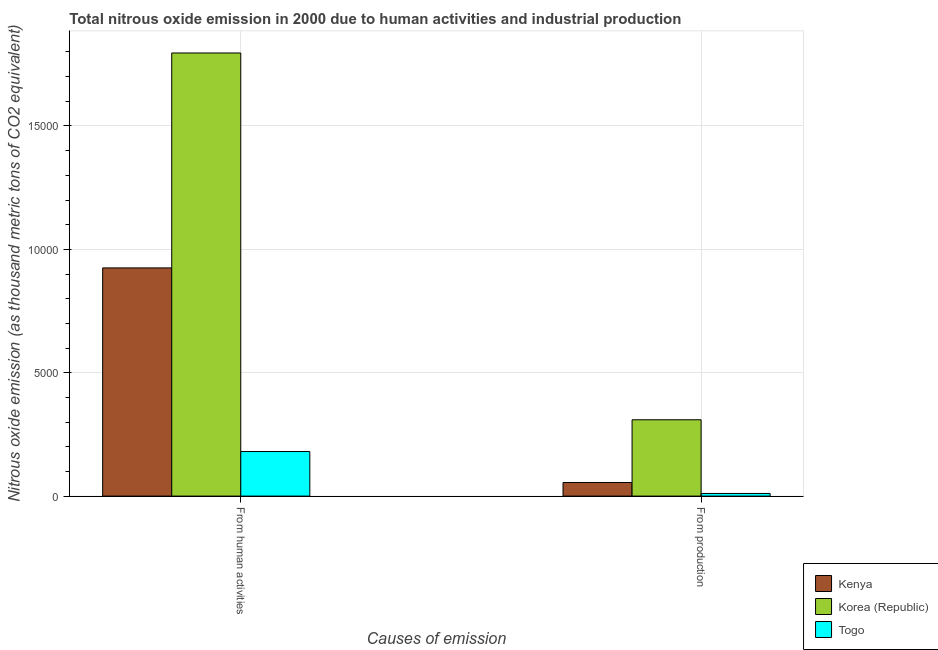How many different coloured bars are there?
Ensure brevity in your answer.  3. Are the number of bars per tick equal to the number of legend labels?
Your answer should be very brief. Yes. How many bars are there on the 2nd tick from the left?
Offer a very short reply. 3. What is the label of the 1st group of bars from the left?
Your response must be concise. From human activities. What is the amount of emissions from human activities in Togo?
Ensure brevity in your answer.  1807. Across all countries, what is the maximum amount of emissions from human activities?
Ensure brevity in your answer.  1.80e+04. Across all countries, what is the minimum amount of emissions generated from industries?
Keep it short and to the point. 107.3. In which country was the amount of emissions generated from industries minimum?
Your answer should be very brief. Togo. What is the total amount of emissions from human activities in the graph?
Offer a very short reply. 2.90e+04. What is the difference between the amount of emissions from human activities in Kenya and that in Korea (Republic)?
Make the answer very short. -8710.5. What is the difference between the amount of emissions from human activities in Togo and the amount of emissions generated from industries in Korea (Republic)?
Your response must be concise. -1286.7. What is the average amount of emissions generated from industries per country?
Give a very brief answer. 1250.83. What is the difference between the amount of emissions from human activities and amount of emissions generated from industries in Korea (Republic)?
Offer a terse response. 1.49e+04. What is the ratio of the amount of emissions from human activities in Korea (Republic) to that in Togo?
Ensure brevity in your answer.  9.94. Is the amount of emissions from human activities in Togo less than that in Kenya?
Provide a succinct answer. Yes. What does the 1st bar from the left in From human activities represents?
Ensure brevity in your answer.  Kenya. What does the 1st bar from the right in From production represents?
Your answer should be compact. Togo. Are the values on the major ticks of Y-axis written in scientific E-notation?
Keep it short and to the point. No. Does the graph contain any zero values?
Ensure brevity in your answer.  No. How many legend labels are there?
Your answer should be very brief. 3. How are the legend labels stacked?
Your answer should be very brief. Vertical. What is the title of the graph?
Offer a terse response. Total nitrous oxide emission in 2000 due to human activities and industrial production. Does "Myanmar" appear as one of the legend labels in the graph?
Your response must be concise. No. What is the label or title of the X-axis?
Provide a short and direct response. Causes of emission. What is the label or title of the Y-axis?
Ensure brevity in your answer.  Nitrous oxide emission (as thousand metric tons of CO2 equivalent). What is the Nitrous oxide emission (as thousand metric tons of CO2 equivalent) in Kenya in From human activities?
Provide a short and direct response. 9247.6. What is the Nitrous oxide emission (as thousand metric tons of CO2 equivalent) in Korea (Republic) in From human activities?
Your answer should be compact. 1.80e+04. What is the Nitrous oxide emission (as thousand metric tons of CO2 equivalent) of Togo in From human activities?
Provide a short and direct response. 1807. What is the Nitrous oxide emission (as thousand metric tons of CO2 equivalent) in Kenya in From production?
Make the answer very short. 551.5. What is the Nitrous oxide emission (as thousand metric tons of CO2 equivalent) in Korea (Republic) in From production?
Provide a short and direct response. 3093.7. What is the Nitrous oxide emission (as thousand metric tons of CO2 equivalent) in Togo in From production?
Make the answer very short. 107.3. Across all Causes of emission, what is the maximum Nitrous oxide emission (as thousand metric tons of CO2 equivalent) of Kenya?
Provide a succinct answer. 9247.6. Across all Causes of emission, what is the maximum Nitrous oxide emission (as thousand metric tons of CO2 equivalent) of Korea (Republic)?
Make the answer very short. 1.80e+04. Across all Causes of emission, what is the maximum Nitrous oxide emission (as thousand metric tons of CO2 equivalent) of Togo?
Ensure brevity in your answer.  1807. Across all Causes of emission, what is the minimum Nitrous oxide emission (as thousand metric tons of CO2 equivalent) in Kenya?
Your answer should be compact. 551.5. Across all Causes of emission, what is the minimum Nitrous oxide emission (as thousand metric tons of CO2 equivalent) in Korea (Republic)?
Your answer should be compact. 3093.7. Across all Causes of emission, what is the minimum Nitrous oxide emission (as thousand metric tons of CO2 equivalent) of Togo?
Offer a terse response. 107.3. What is the total Nitrous oxide emission (as thousand metric tons of CO2 equivalent) in Kenya in the graph?
Ensure brevity in your answer.  9799.1. What is the total Nitrous oxide emission (as thousand metric tons of CO2 equivalent) in Korea (Republic) in the graph?
Offer a very short reply. 2.11e+04. What is the total Nitrous oxide emission (as thousand metric tons of CO2 equivalent) in Togo in the graph?
Give a very brief answer. 1914.3. What is the difference between the Nitrous oxide emission (as thousand metric tons of CO2 equivalent) of Kenya in From human activities and that in From production?
Make the answer very short. 8696.1. What is the difference between the Nitrous oxide emission (as thousand metric tons of CO2 equivalent) of Korea (Republic) in From human activities and that in From production?
Offer a terse response. 1.49e+04. What is the difference between the Nitrous oxide emission (as thousand metric tons of CO2 equivalent) in Togo in From human activities and that in From production?
Provide a succinct answer. 1699.7. What is the difference between the Nitrous oxide emission (as thousand metric tons of CO2 equivalent) of Kenya in From human activities and the Nitrous oxide emission (as thousand metric tons of CO2 equivalent) of Korea (Republic) in From production?
Offer a terse response. 6153.9. What is the difference between the Nitrous oxide emission (as thousand metric tons of CO2 equivalent) in Kenya in From human activities and the Nitrous oxide emission (as thousand metric tons of CO2 equivalent) in Togo in From production?
Give a very brief answer. 9140.3. What is the difference between the Nitrous oxide emission (as thousand metric tons of CO2 equivalent) of Korea (Republic) in From human activities and the Nitrous oxide emission (as thousand metric tons of CO2 equivalent) of Togo in From production?
Your answer should be compact. 1.79e+04. What is the average Nitrous oxide emission (as thousand metric tons of CO2 equivalent) in Kenya per Causes of emission?
Give a very brief answer. 4899.55. What is the average Nitrous oxide emission (as thousand metric tons of CO2 equivalent) in Korea (Republic) per Causes of emission?
Ensure brevity in your answer.  1.05e+04. What is the average Nitrous oxide emission (as thousand metric tons of CO2 equivalent) of Togo per Causes of emission?
Offer a very short reply. 957.15. What is the difference between the Nitrous oxide emission (as thousand metric tons of CO2 equivalent) in Kenya and Nitrous oxide emission (as thousand metric tons of CO2 equivalent) in Korea (Republic) in From human activities?
Offer a terse response. -8710.5. What is the difference between the Nitrous oxide emission (as thousand metric tons of CO2 equivalent) in Kenya and Nitrous oxide emission (as thousand metric tons of CO2 equivalent) in Togo in From human activities?
Ensure brevity in your answer.  7440.6. What is the difference between the Nitrous oxide emission (as thousand metric tons of CO2 equivalent) of Korea (Republic) and Nitrous oxide emission (as thousand metric tons of CO2 equivalent) of Togo in From human activities?
Give a very brief answer. 1.62e+04. What is the difference between the Nitrous oxide emission (as thousand metric tons of CO2 equivalent) of Kenya and Nitrous oxide emission (as thousand metric tons of CO2 equivalent) of Korea (Republic) in From production?
Your answer should be very brief. -2542.2. What is the difference between the Nitrous oxide emission (as thousand metric tons of CO2 equivalent) in Kenya and Nitrous oxide emission (as thousand metric tons of CO2 equivalent) in Togo in From production?
Offer a terse response. 444.2. What is the difference between the Nitrous oxide emission (as thousand metric tons of CO2 equivalent) of Korea (Republic) and Nitrous oxide emission (as thousand metric tons of CO2 equivalent) of Togo in From production?
Your response must be concise. 2986.4. What is the ratio of the Nitrous oxide emission (as thousand metric tons of CO2 equivalent) of Kenya in From human activities to that in From production?
Keep it short and to the point. 16.77. What is the ratio of the Nitrous oxide emission (as thousand metric tons of CO2 equivalent) of Korea (Republic) in From human activities to that in From production?
Offer a very short reply. 5.8. What is the ratio of the Nitrous oxide emission (as thousand metric tons of CO2 equivalent) in Togo in From human activities to that in From production?
Your response must be concise. 16.84. What is the difference between the highest and the second highest Nitrous oxide emission (as thousand metric tons of CO2 equivalent) of Kenya?
Ensure brevity in your answer.  8696.1. What is the difference between the highest and the second highest Nitrous oxide emission (as thousand metric tons of CO2 equivalent) in Korea (Republic)?
Offer a very short reply. 1.49e+04. What is the difference between the highest and the second highest Nitrous oxide emission (as thousand metric tons of CO2 equivalent) of Togo?
Offer a terse response. 1699.7. What is the difference between the highest and the lowest Nitrous oxide emission (as thousand metric tons of CO2 equivalent) in Kenya?
Offer a terse response. 8696.1. What is the difference between the highest and the lowest Nitrous oxide emission (as thousand metric tons of CO2 equivalent) of Korea (Republic)?
Offer a very short reply. 1.49e+04. What is the difference between the highest and the lowest Nitrous oxide emission (as thousand metric tons of CO2 equivalent) in Togo?
Offer a very short reply. 1699.7. 